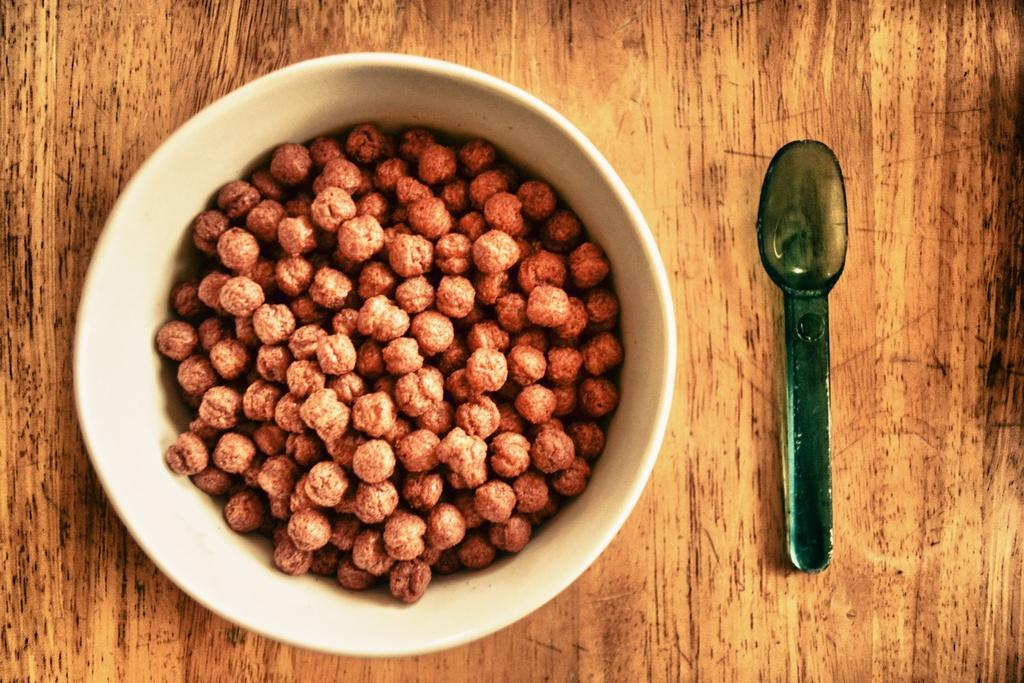What type of utensils are present in the image? There are spoons in the image. What are the spoons used for in the image? The spoons are used for eating the food item in the bowl. What is the primary container for the food item in the image? There are bowls in the image that contain the food item. What is the material of the object that supports the bowl and spoon? The bowl and spoon are placed on a wooden object. What type of clam is being served in the rice-filled bowl in the image? There is no clam or rice present in the image; it only contains a food item in the bowl. 